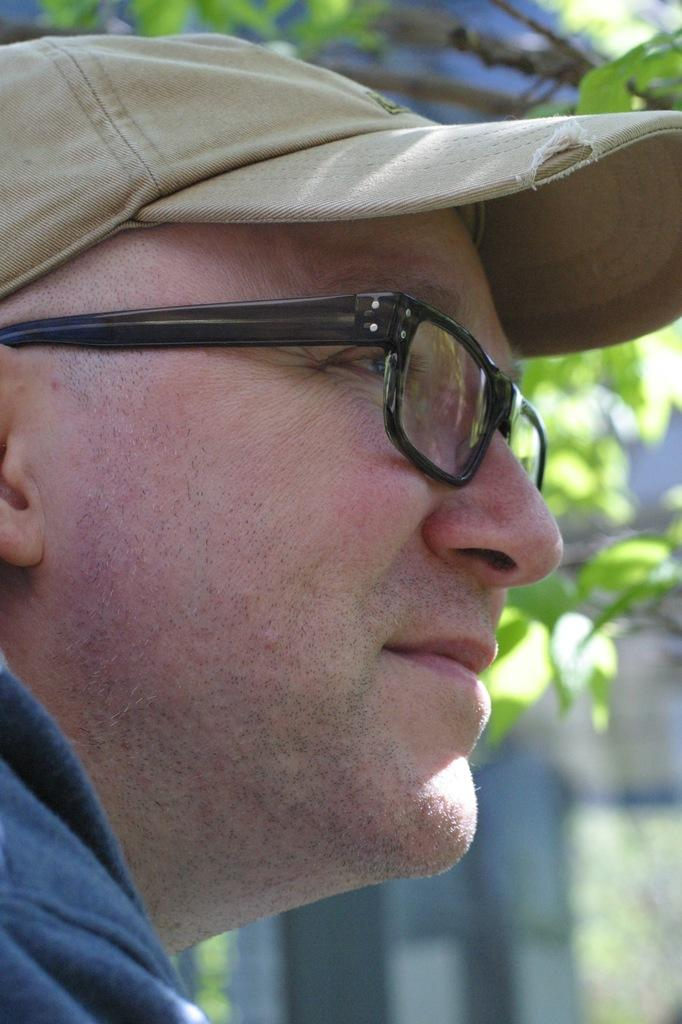Who is the main subject in the picture? There is a man in the picture. What is the man wearing on his head? The man is wearing a hat. What accessory is the man wearing on his face? The man is wearing spectacles. How would you describe the background of the man in the picture? The background of the man is blurred. What type of line can be seen cutting through the man's hat in the image? There is no line cutting through the man's hat in the image. 